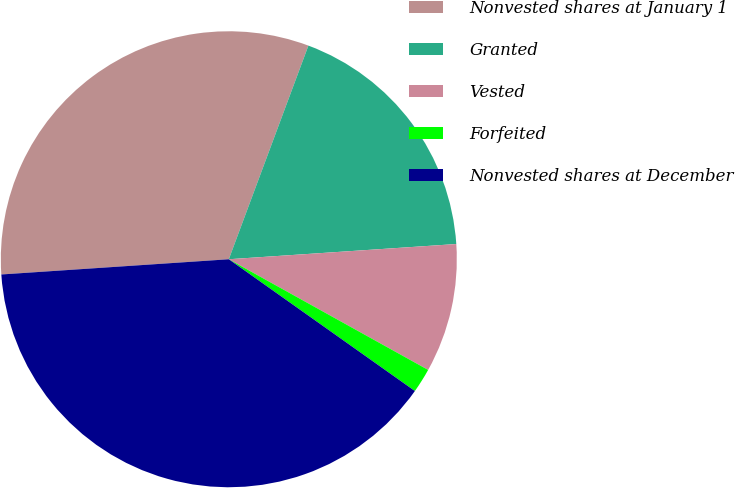<chart> <loc_0><loc_0><loc_500><loc_500><pie_chart><fcel>Nonvested shares at January 1<fcel>Granted<fcel>Vested<fcel>Forfeited<fcel>Nonvested shares at December<nl><fcel>31.74%<fcel>18.26%<fcel>9.13%<fcel>1.74%<fcel>39.13%<nl></chart> 